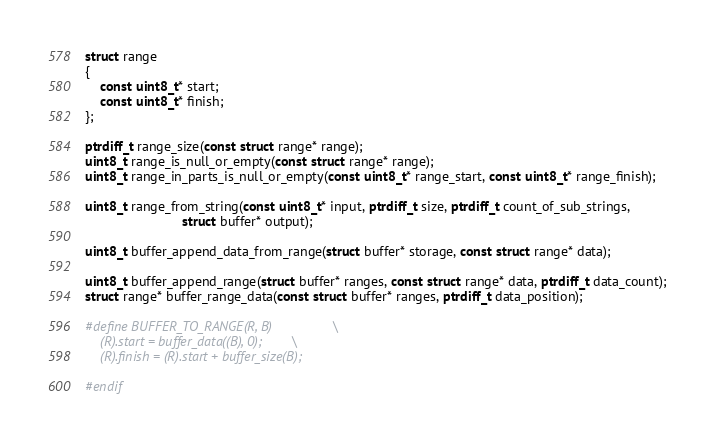<code> <loc_0><loc_0><loc_500><loc_500><_C_>struct range
{
	const uint8_t* start;
	const uint8_t* finish;
};

ptrdiff_t range_size(const struct range* range);
uint8_t range_is_null_or_empty(const struct range* range);
uint8_t range_in_parts_is_null_or_empty(const uint8_t* range_start, const uint8_t* range_finish);

uint8_t range_from_string(const uint8_t* input, ptrdiff_t size, ptrdiff_t count_of_sub_strings,
						  struct buffer* output);

uint8_t buffer_append_data_from_range(struct buffer* storage, const struct range* data);

uint8_t buffer_append_range(struct buffer* ranges, const struct range* data, ptrdiff_t data_count);
struct range* buffer_range_data(const struct buffer* ranges, ptrdiff_t data_position);

#define BUFFER_TO_RANGE(R, B)				\
	(R).start = buffer_data((B), 0);		\
	(R).finish = (R).start + buffer_size(B);

#endif
</code> 